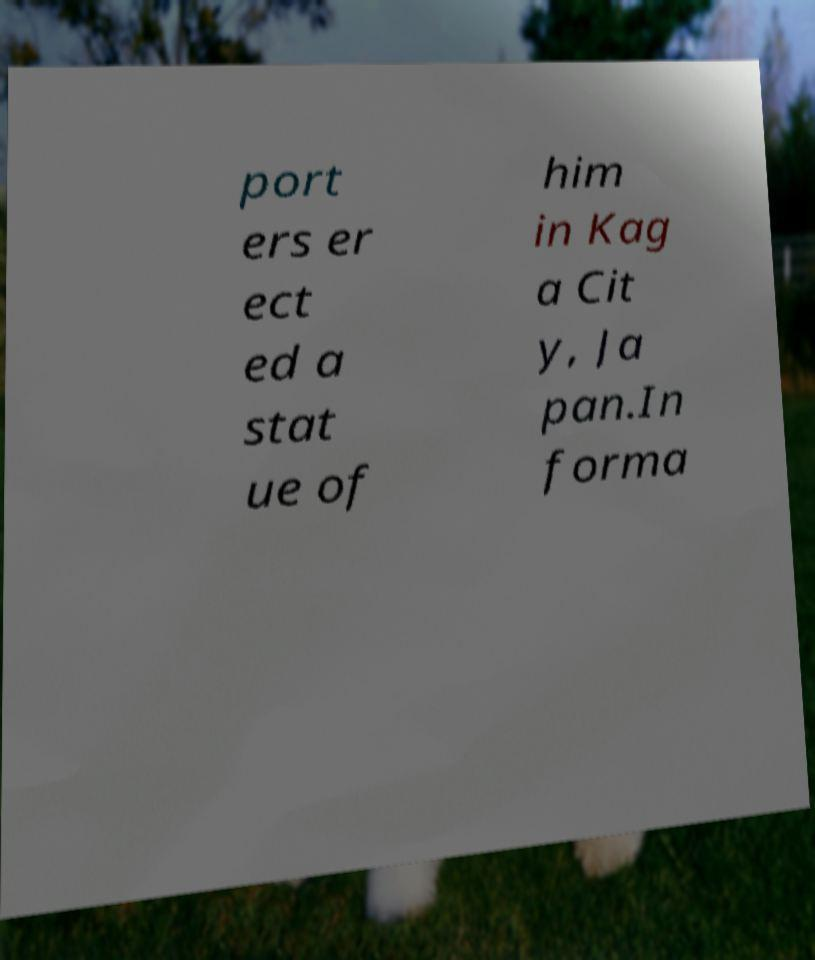What messages or text are displayed in this image? I need them in a readable, typed format. port ers er ect ed a stat ue of him in Kag a Cit y, Ja pan.In forma 